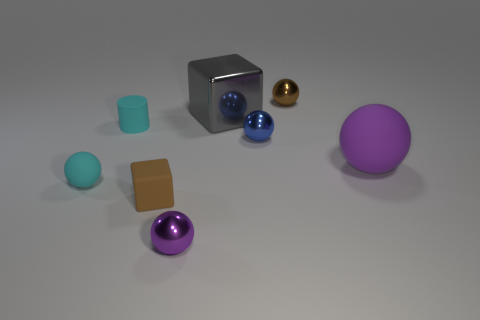Add 2 rubber objects. How many objects exist? 10 Subtract all brown metallic spheres. How many spheres are left? 4 Subtract all blue cylinders. How many purple balls are left? 2 Subtract 1 spheres. How many spheres are left? 4 Add 4 small brown rubber cylinders. How many small brown rubber cylinders exist? 4 Subtract all gray blocks. How many blocks are left? 1 Subtract 0 purple blocks. How many objects are left? 8 Subtract all spheres. How many objects are left? 3 Subtract all blue cylinders. Subtract all brown balls. How many cylinders are left? 1 Subtract all large green matte cylinders. Subtract all big purple rubber balls. How many objects are left? 7 